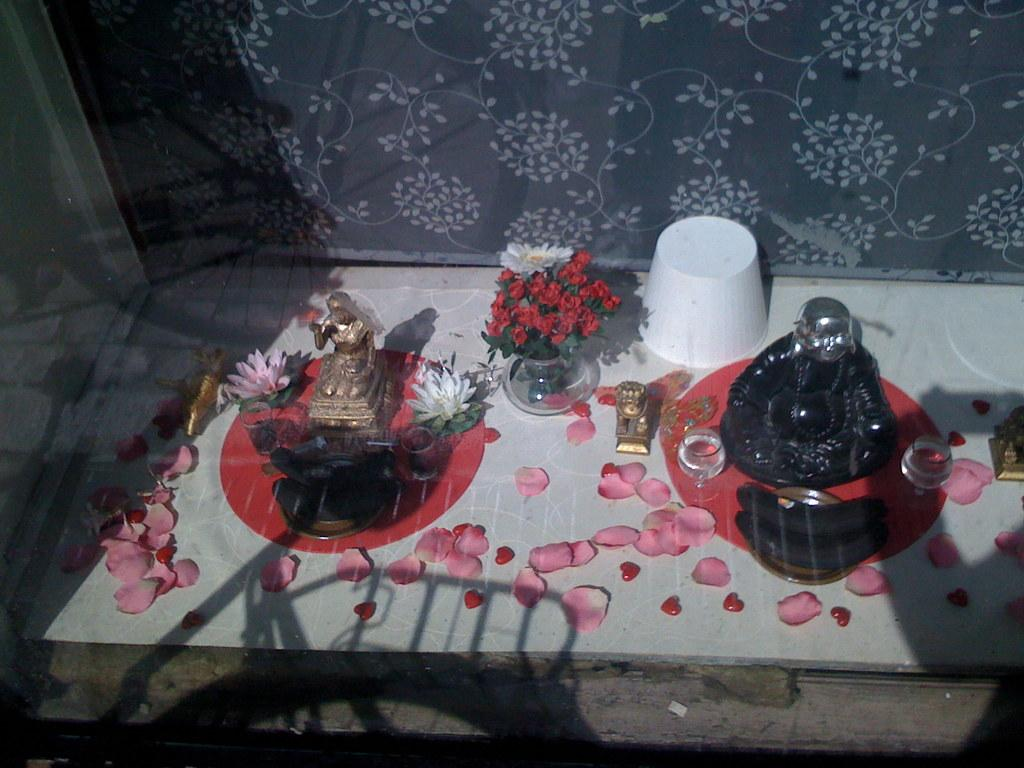What type of objects can be seen in the image? There are statues, flowers, vases, and glasses on a sheet in the image. What is present around the flowers? Petals are present in the image. What type of containers are used for the flowers? Vases are used for the flowers. What can be seen in the background of the image? There is a wall in the background of the image. What else is visible in the image? Shadows are visible in the image. Who is the owner of the box in the image? There is no box present in the image. 